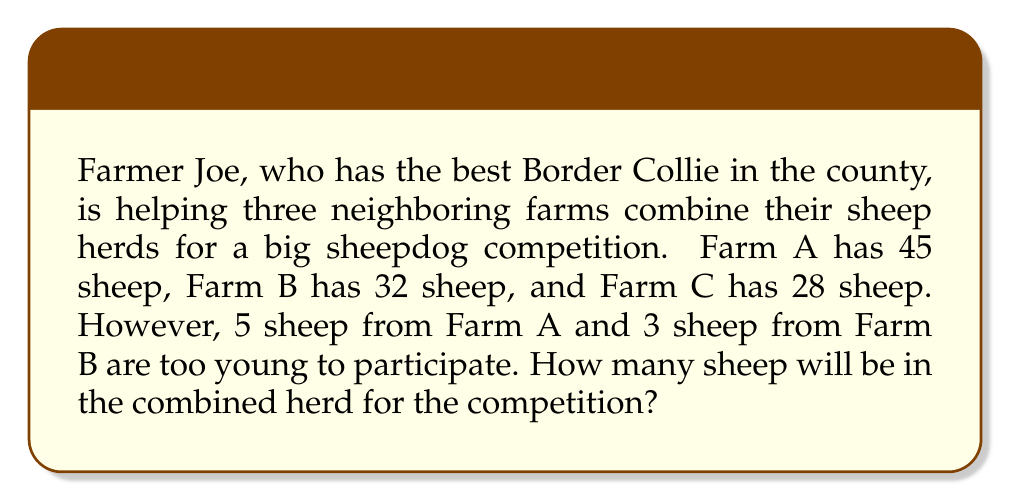Solve this math problem. Let's approach this step-by-step:

1. First, we need to calculate the total number of sheep from all three farms:
   $$\text{Total sheep} = \text{Farm A} + \text{Farm B} + \text{Farm C}$$
   $$\text{Total sheep} = 45 + 32 + 28 = 105$$

2. Now, we need to subtract the sheep that are too young to participate:
   - 5 sheep from Farm A
   - 3 sheep from Farm B

3. We can represent this as:
   $$\text{Participating sheep} = \text{Total sheep} - \text{Young sheep}$$
   $$\text{Participating sheep} = 105 - (5 + 3)$$
   $$\text{Participating sheep} = 105 - 8 = 97$$

Therefore, the combined herd for the competition will have 97 sheep.
Answer: 97 sheep 